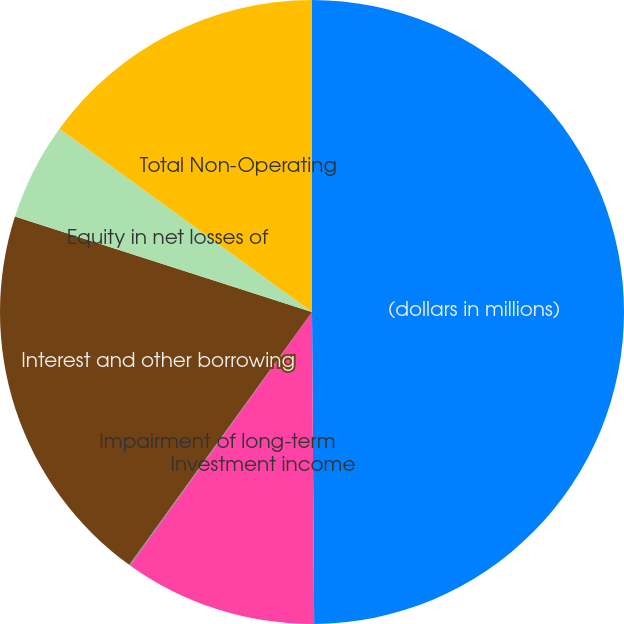Convert chart to OTSL. <chart><loc_0><loc_0><loc_500><loc_500><pie_chart><fcel>(dollars in millions)<fcel>Investment income<fcel>Impairment of long-term<fcel>Interest and other borrowing<fcel>Equity in net losses of<fcel>Total Non-Operating<nl><fcel>49.89%<fcel>10.02%<fcel>0.05%<fcel>19.99%<fcel>5.04%<fcel>15.01%<nl></chart> 